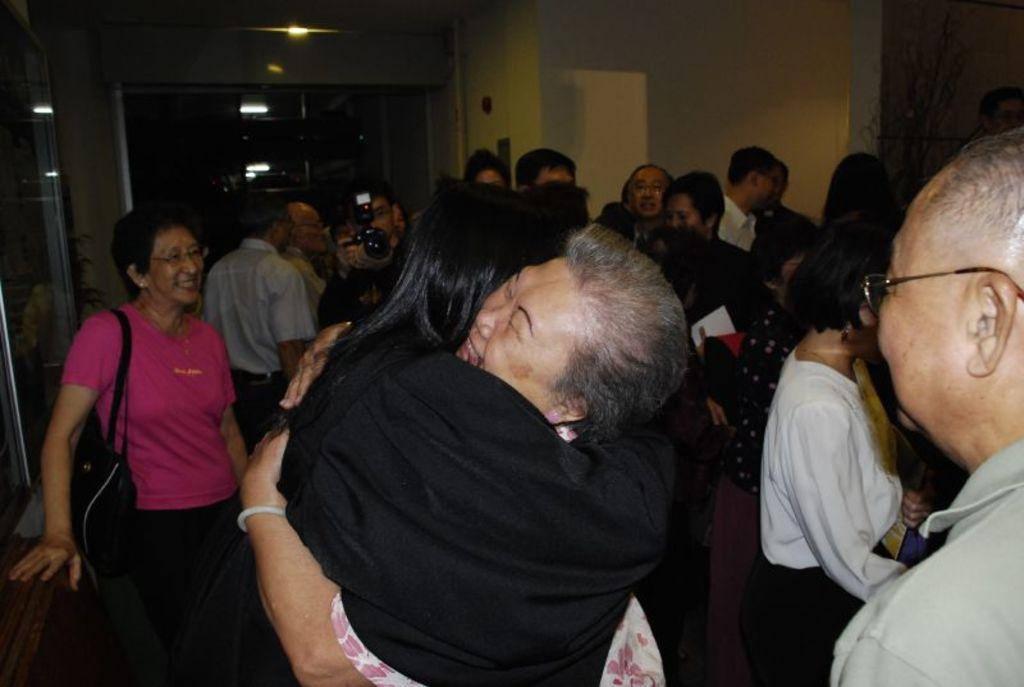Could you give a brief overview of what you see in this image? in this picture, we see many people are standing. The woman in white dress is hugging the woman in black dress. Behind them, the woman in pink T-shirt who is wearing a handbag is smiling. The man in the middle of the picture is clicking photos on the camera. On the right side, we see a white wall. At the top of the picture, we see the ceiling of the room. This picture is clicked in the dark. 